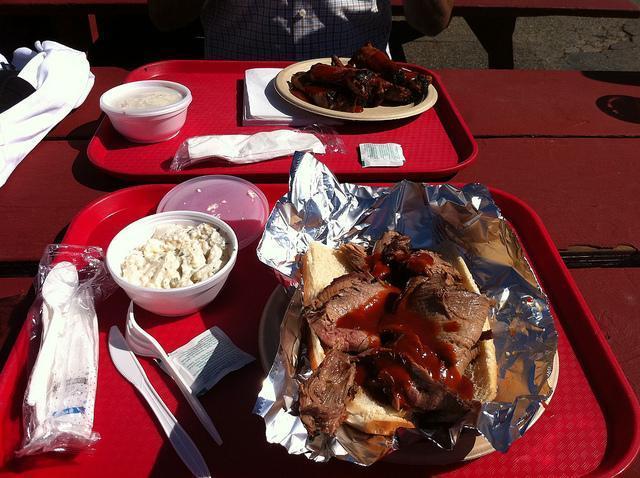How many sandwiches can be seen?
Give a very brief answer. 2. How many bowls are visible?
Give a very brief answer. 2. 